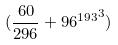Convert formula to latex. <formula><loc_0><loc_0><loc_500><loc_500>( \frac { 6 0 } { 2 9 6 } + { 9 6 ^ { 1 9 3 } } ^ { 3 } )</formula> 